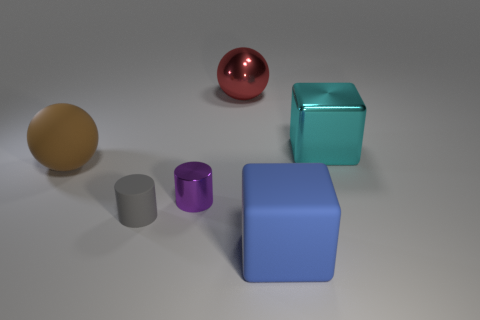How many other things are the same size as the brown matte ball?
Offer a very short reply. 3. Are the brown sphere and the cube that is in front of the large brown matte object made of the same material?
Offer a terse response. Yes. Are there the same number of brown rubber objects that are in front of the matte cube and tiny purple objects right of the big cyan block?
Your answer should be very brief. Yes. What material is the big brown thing?
Ensure brevity in your answer.  Rubber. The other ball that is the same size as the red metal sphere is what color?
Give a very brief answer. Brown. There is a shiny thing that is on the right side of the red shiny sphere; is there a purple metal cylinder that is behind it?
Ensure brevity in your answer.  No. What number of spheres are either purple shiny things or brown things?
Your answer should be compact. 1. There is a ball behind the large ball in front of the big ball to the right of the tiny gray rubber cylinder; how big is it?
Your response must be concise. Large. Are there any blue blocks in front of the big blue rubber block?
Provide a succinct answer. No. How many objects are either shiny things that are to the right of the large blue object or small purple cylinders?
Offer a terse response. 2. 